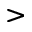<formula> <loc_0><loc_0><loc_500><loc_500>></formula> 